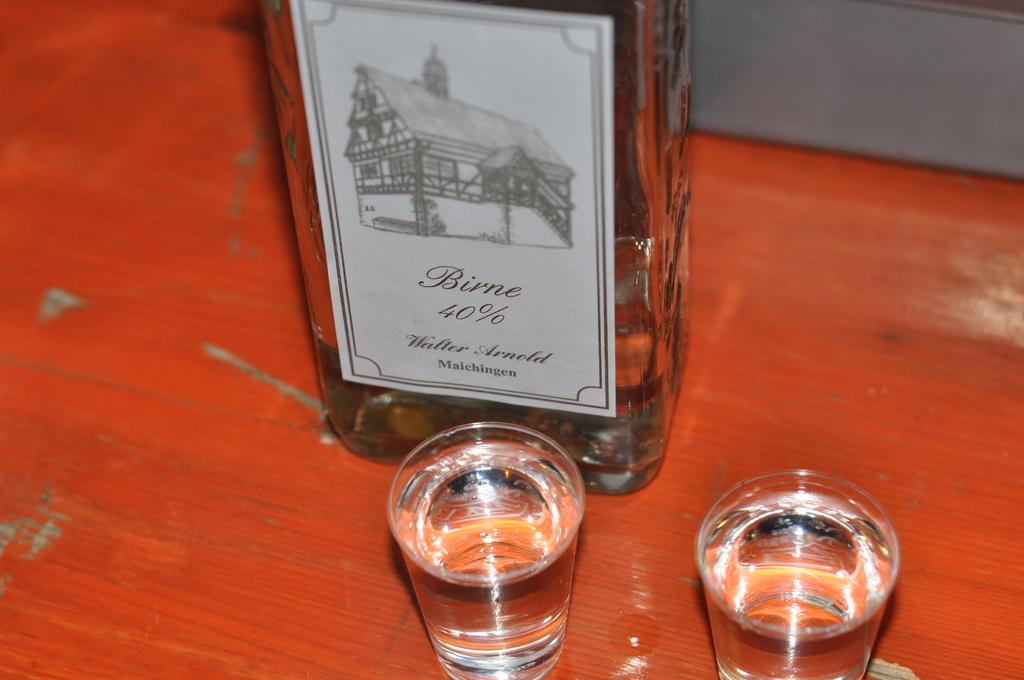What is on the bottle in the image? There is a sticker on the bottle in the image. What can be seen in the glasses in the image? There are liquids in the glasses in the image. What type of surface is visible in the image? The wooden surface is present in the image. How many geese are sitting on the wooden surface in the image? There are no geese present in the image; it only features a bottle, glasses, and a wooden surface. What type of language is spoken by the geese in the image? There are no geese present in the image, so it is not possible to determine the language they might speak. 